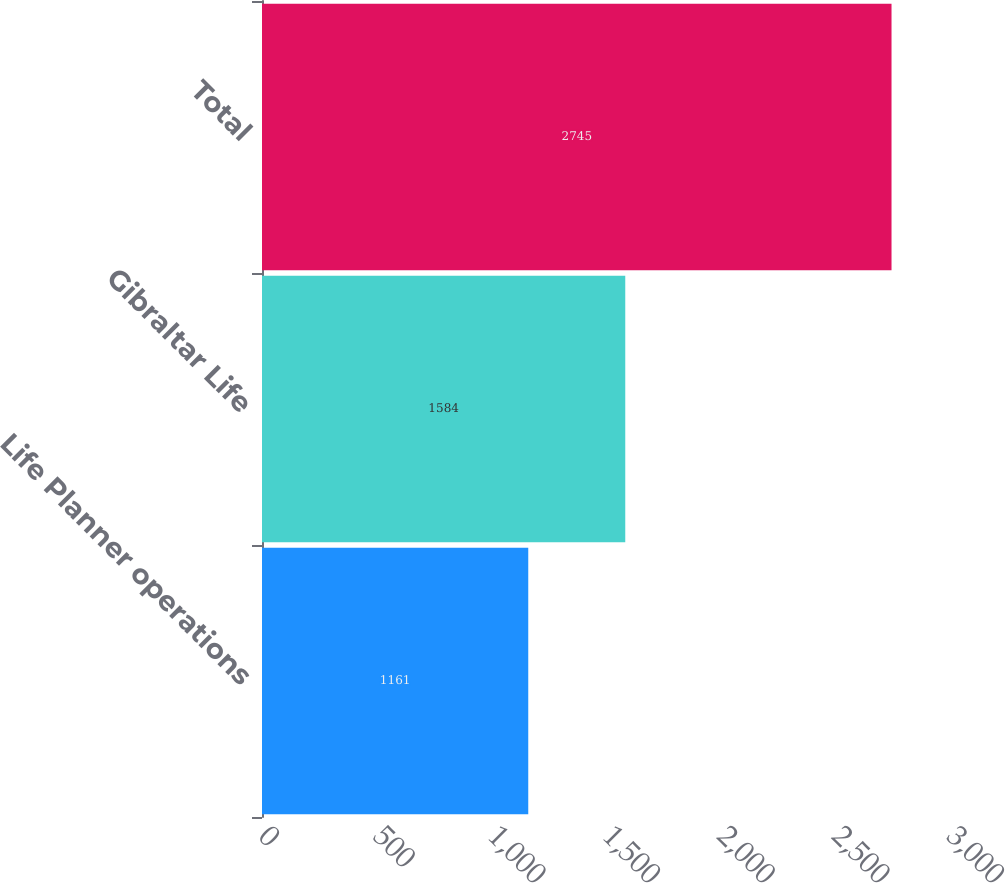Convert chart. <chart><loc_0><loc_0><loc_500><loc_500><bar_chart><fcel>Life Planner operations<fcel>Gibraltar Life<fcel>Total<nl><fcel>1161<fcel>1584<fcel>2745<nl></chart> 